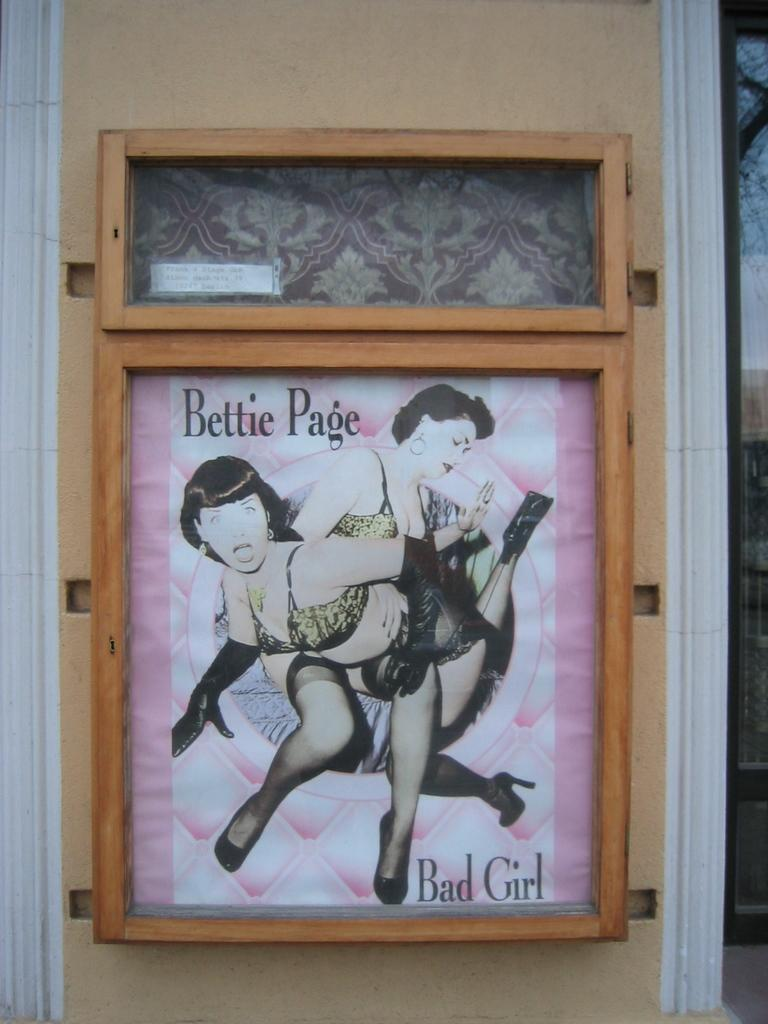Provide a one-sentence caption for the provided image. a framed picture of two women that are called bettie page. 